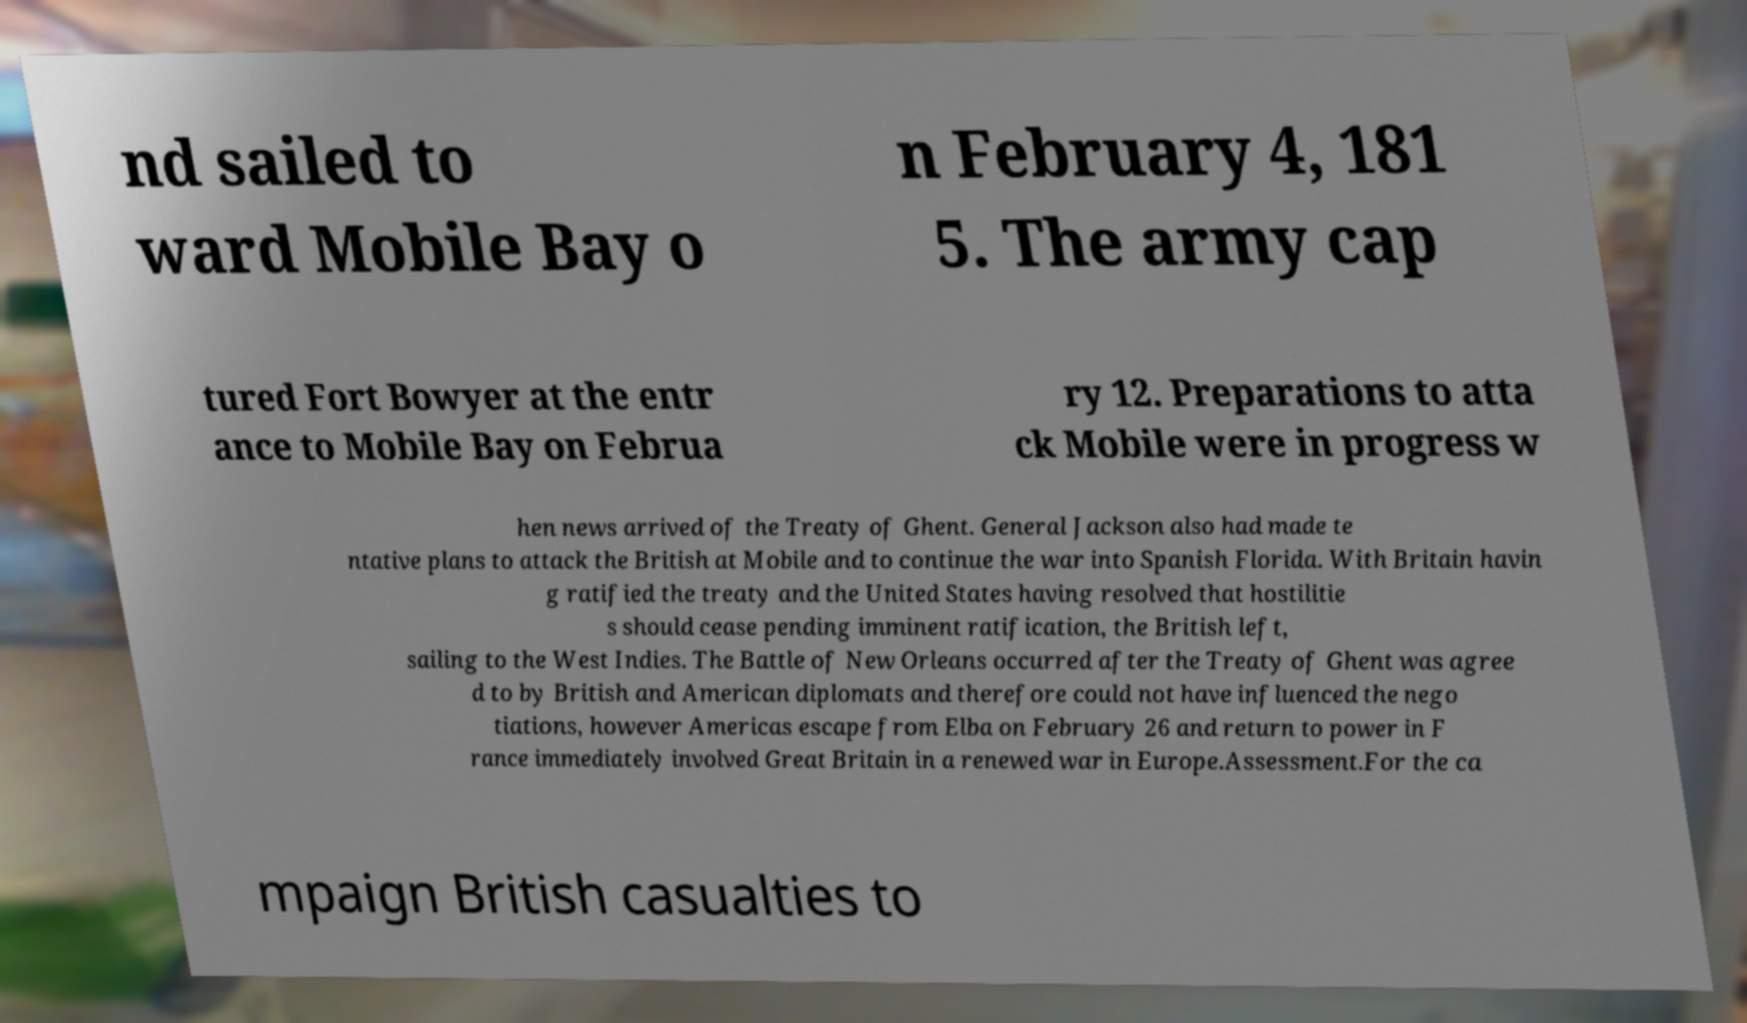Could you extract and type out the text from this image? nd sailed to ward Mobile Bay o n February 4, 181 5. The army cap tured Fort Bowyer at the entr ance to Mobile Bay on Februa ry 12. Preparations to atta ck Mobile were in progress w hen news arrived of the Treaty of Ghent. General Jackson also had made te ntative plans to attack the British at Mobile and to continue the war into Spanish Florida. With Britain havin g ratified the treaty and the United States having resolved that hostilitie s should cease pending imminent ratification, the British left, sailing to the West Indies. The Battle of New Orleans occurred after the Treaty of Ghent was agree d to by British and American diplomats and therefore could not have influenced the nego tiations, however Americas escape from Elba on February 26 and return to power in F rance immediately involved Great Britain in a renewed war in Europe.Assessment.For the ca mpaign British casualties to 